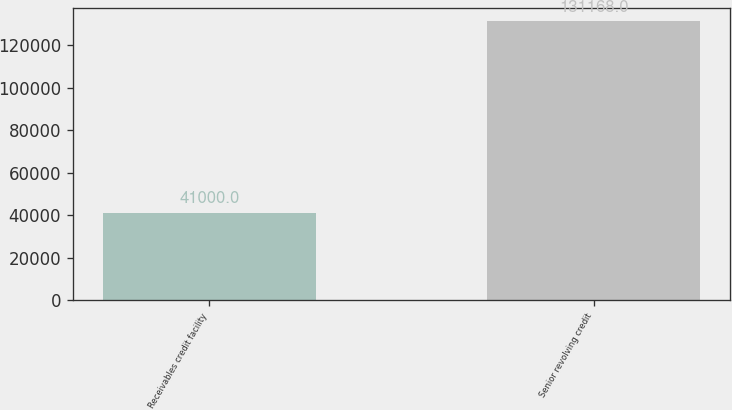Convert chart. <chart><loc_0><loc_0><loc_500><loc_500><bar_chart><fcel>Receivables credit facility<fcel>Senior revolving credit<nl><fcel>41000<fcel>131168<nl></chart> 